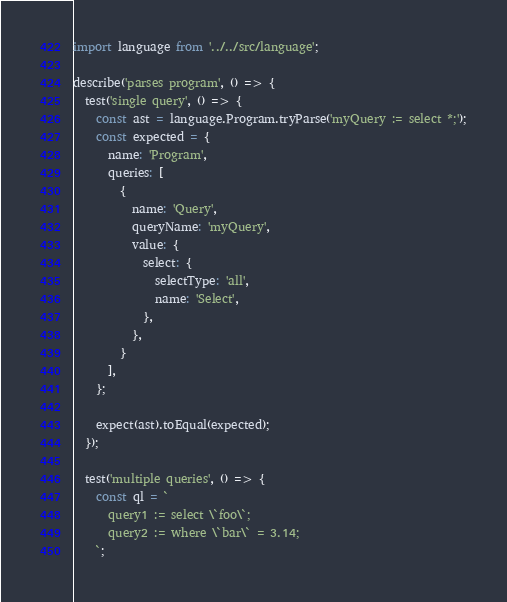Convert code to text. <code><loc_0><loc_0><loc_500><loc_500><_JavaScript_>import language from '../../src/language';

describe('parses program', () => {
  test('single query', () => {
    const ast = language.Program.tryParse('myQuery := select *;');
    const expected = {
      name: 'Program',
      queries: [
        {
          name: 'Query',
          queryName: 'myQuery',
          value: {
            select: {
              selectType: 'all',
              name: 'Select',
            },
          },
        }
      ],
    };

    expect(ast).toEqual(expected);
  });

  test('multiple queries', () => {
    const ql = `
      query1 := select \`foo\`;
      query2 := where \`bar\` = 3.14;
    `;</code> 